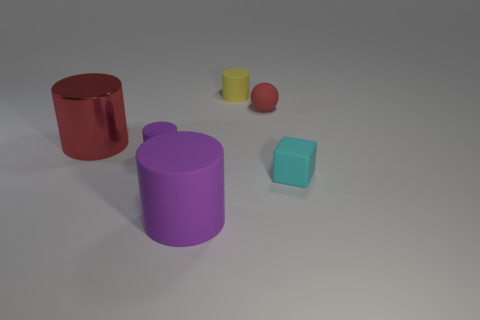Add 3 large blue cubes. How many objects exist? 9 Subtract all yellow rubber cylinders. How many cylinders are left? 3 Subtract all cylinders. How many objects are left? 2 Subtract 1 balls. How many balls are left? 0 Subtract all brown cubes. How many purple cylinders are left? 2 Subtract all small yellow objects. Subtract all big shiny things. How many objects are left? 4 Add 2 yellow rubber cylinders. How many yellow rubber cylinders are left? 3 Add 6 brown things. How many brown things exist? 6 Subtract all red cylinders. How many cylinders are left? 3 Subtract 0 blue cylinders. How many objects are left? 6 